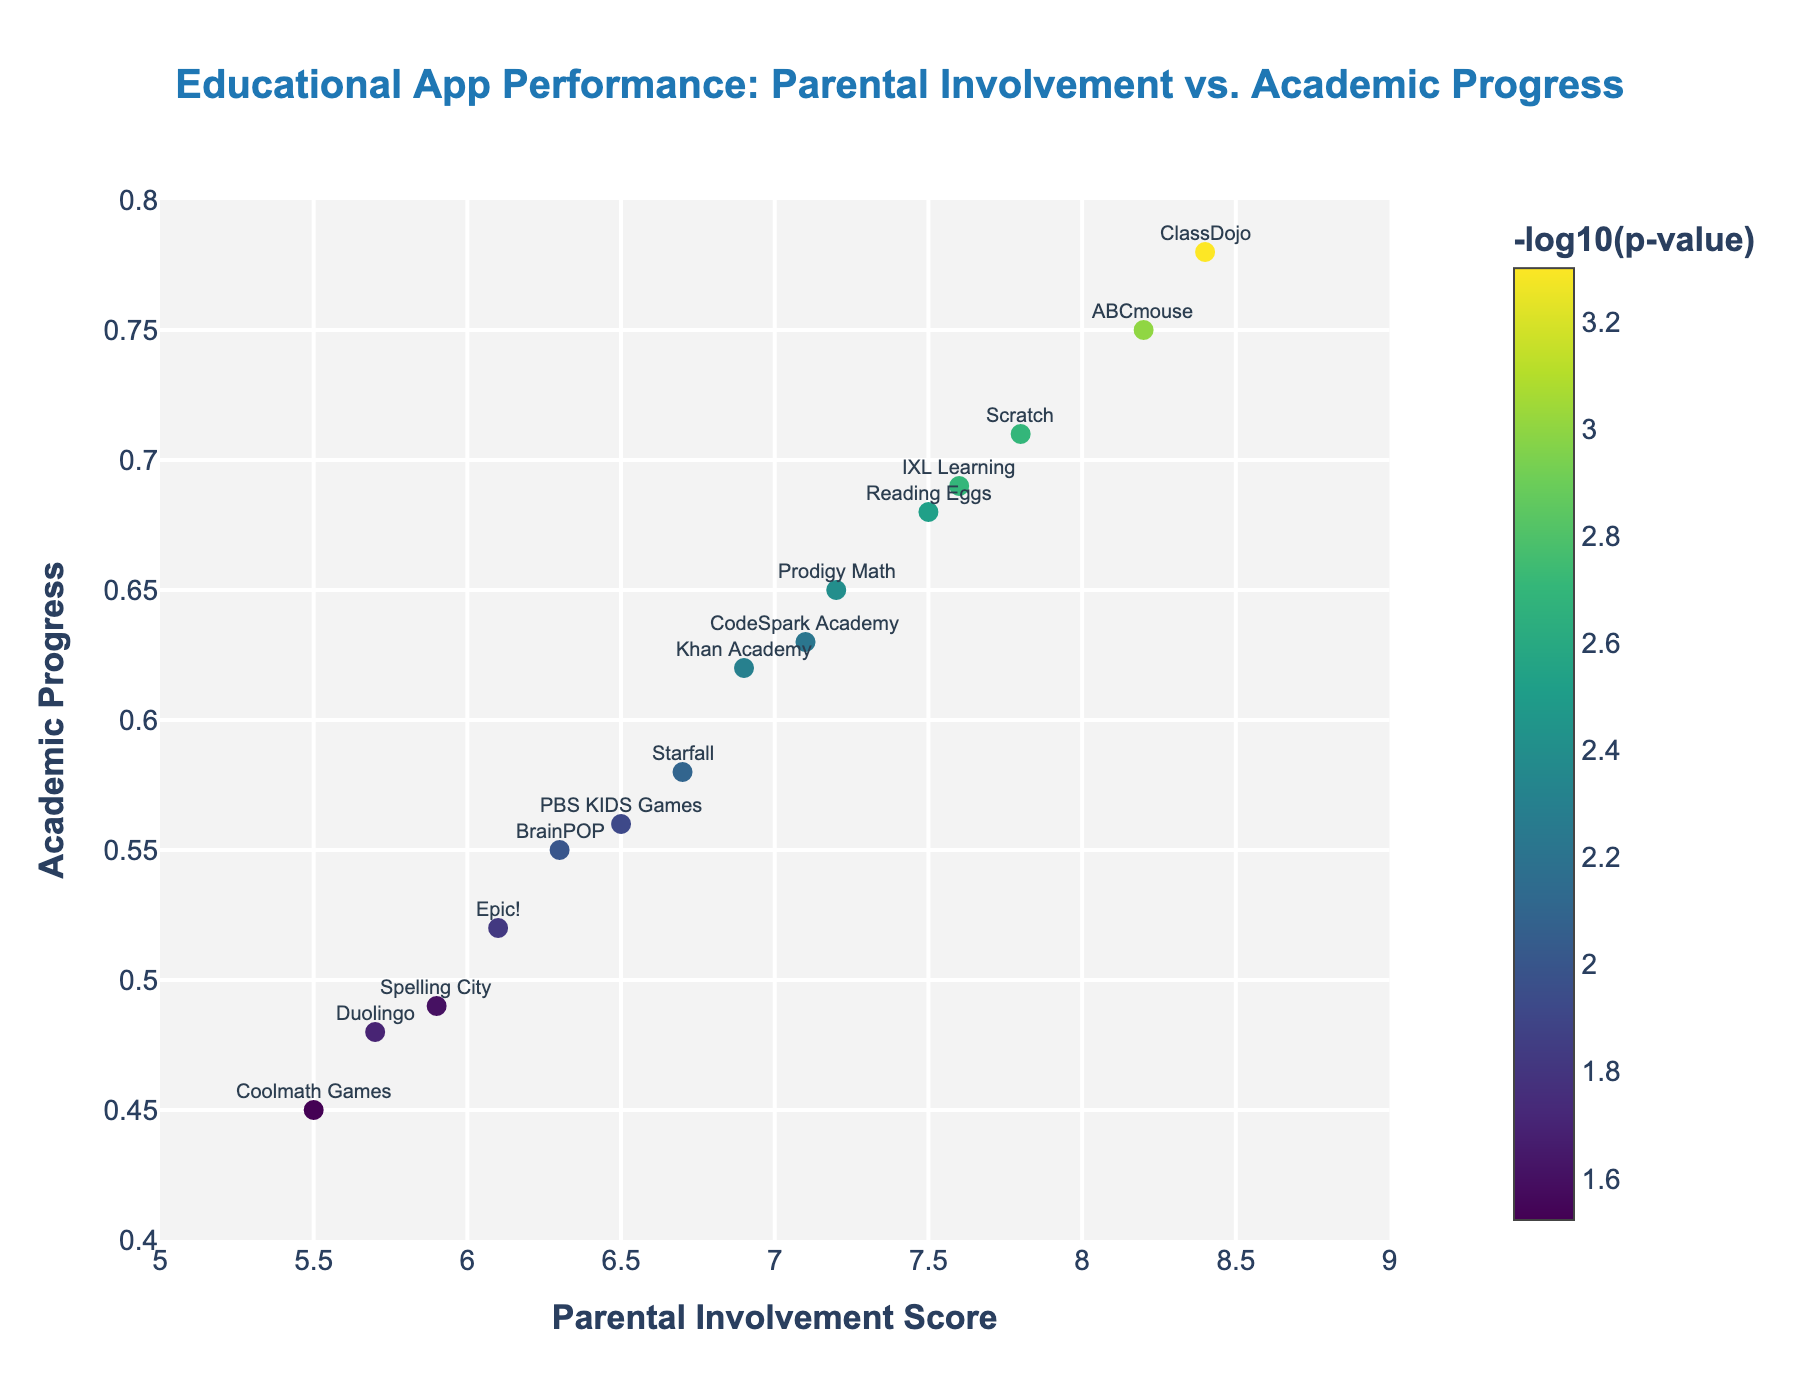What is the title of the figure? The title is the large, bold text at the top of the figure, providing an overview of what the plot is about.
Answer: Educational App Performance: Parental Involvement vs. Academic Progress Which app has the highest academic progress? Look for the data point with the highest value on the y-axis, representing academic progress, and note the app labeled at that point.
Answer: ClassDojo What is the parental involvement score and academic progress for ABCmouse? Identify the point for ABCmouse by checking its label, then read the corresponding values on the x-axis and y-axis.
Answer: 8.2, 0.75 Which apps have a p-value ≤ 0.005 and how do they perform in academic progress? Find the points with a -log10(p-value) above 2.3 (since -log10(0.005) is approximately 2.3) and extract their y-axis values for academic progress. Check their labels for app names.
Answer: ClassDojo (0.78), ABCmouse (0.75), Scratch (0.71), Reading Eggs (0.68), IXL Learning (0.69), Prodigy Math (0.65), Khan Academy (0.62), CodeSpark Academy (0.63) Which two apps have the closest parental involvement scores, and what are their scores and academic progress? Compare the x-axis values to determine which two apps have the closest values and note both their x-axis and y-axis values.
Answer: Reading Eggs (7.5, 0.68) and IXL Learning (7.6, 0.69) Is there a correlation between parental involvement and academic progress? Observe the overall trend in the scatter plot. If higher parental involvement scores (x-axis) generally correspond to higher academic progress scores (y-axis), there is a positive correlation.
Answer: Yes What app has the highest parental involvement score and what is its academic progress? Locate the point farthest to the right on the x-axis, identify the app label, and note the corresponding y-axis value.
Answer: ClassDojo (0.78) Which app has the lowest academic progress, and what is its parental involvement score? Find the point with the lowest y-axis value, identify the app label, and read the corresponding x-axis score.
Answer: Coolmath Games, 5.5 